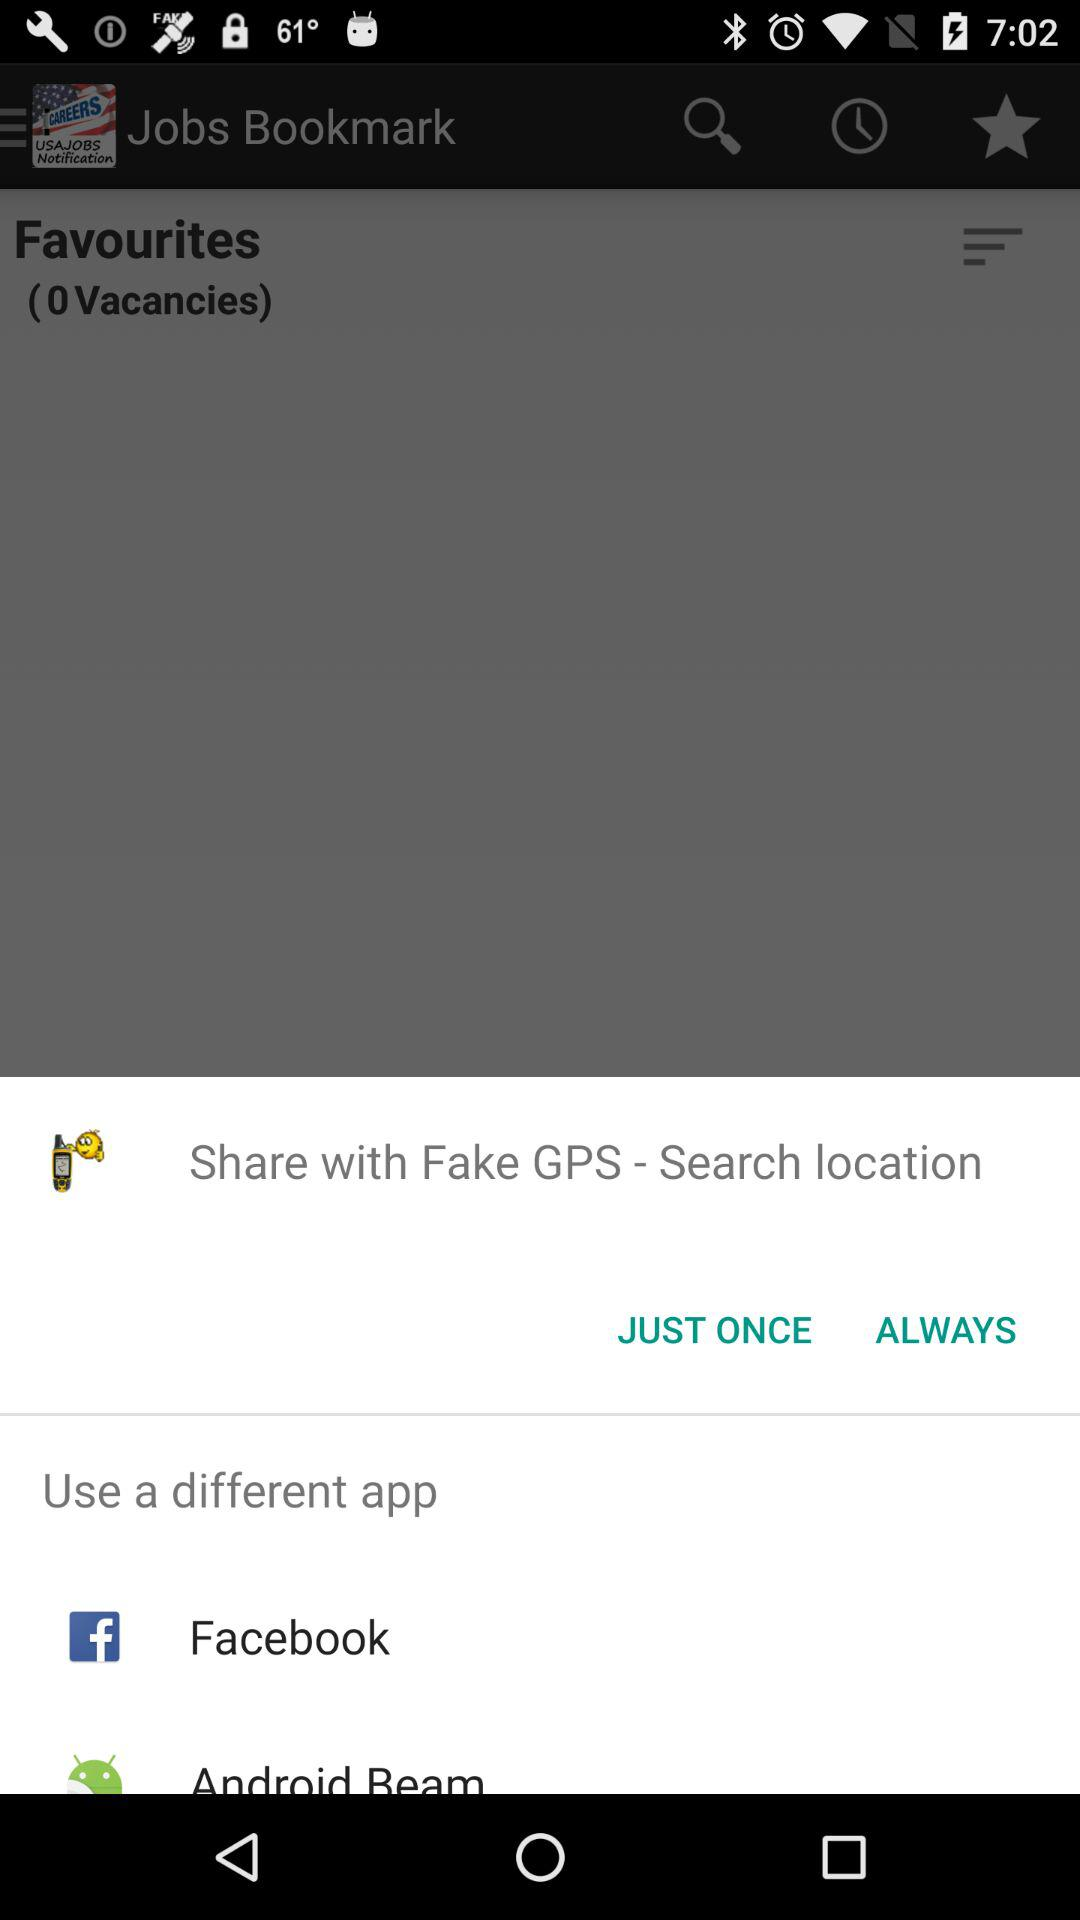What application can I use to share? You can use "Fake GPS - Search location", "Facebook" and "Android Beam" to share. 